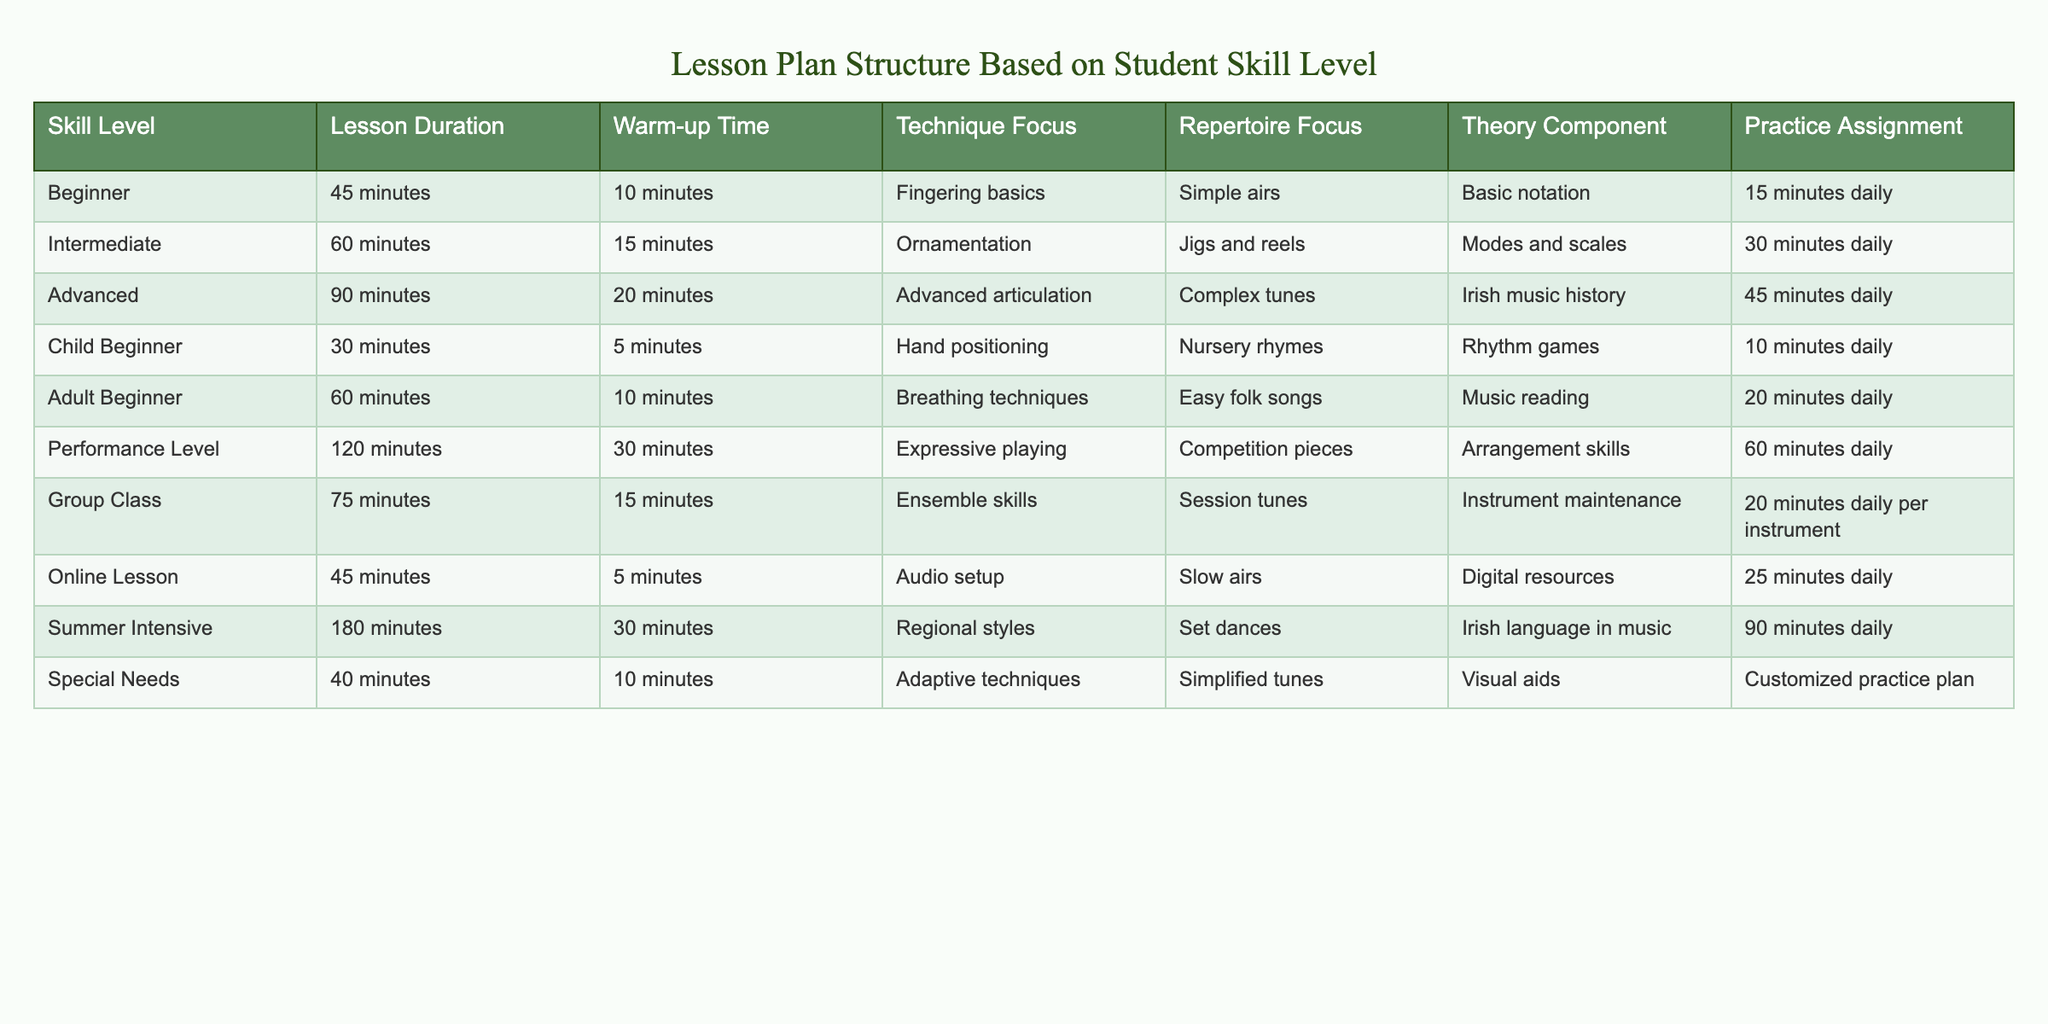What is the lesson duration for a beginner? According to the table, the lesson duration for a beginner is 45 minutes, as stated in the "Lesson Duration" column for the "Beginner" skill level.
Answer: 45 minutes How much warm-up time is allocated for the performance level? The table indicates that the warm-up time for the performance level is 30 minutes, as found in the "Warm-up Time" column for that skill level.
Answer: 30 minutes Which skill level has the longest lesson duration? By examining the “Lesson Duration” column, the performance level has the longest lesson duration of 120 minutes, which is the highest value in that column.
Answer: Performance Level Is the practice assignment for child beginners longer than for adult beginners? The practice assignment for child beginners is 10 minutes daily while for adult beginners it is 20 minutes daily. Therefore, it is not longer for child beginners; it is shorter.
Answer: No What is the combined lesson duration for intermediate and advanced students? The lesson duration for intermediate students is 60 minutes and for advanced students is 90 minutes. Adding these together: 60 + 90 = 150 minutes.
Answer: 150 minutes How many skill levels have a warm-up time of 10 minutes or less? From the table, the skill levels with a warm-up time of 10 minutes or less are beginner (10 minutes), child beginner (5 minutes), adult beginner (10 minutes), and special needs (10 minutes). This totals to four skill levels.
Answer: 4 What is the average practice assignment time across all skill levels? The practice assignment times are 15, 30, 45, 10, 20, 60, 20, 25, 90, and customized practice plan. Ignoring the qualitative last item and summing the rest gives (15 + 30 + 45 + 10 + 20 + 60 + 20 + 25 + 90) = 315 minutes over 9 levels. Therefore, the average is 315 / 9 = 35 minutes.
Answer: 35 minutes Do all skill levels include a theory component in their lesson plans? A review of the table shows that every skill level has a theory component specified, so the answer is yes; all skill levels include a theory component.
Answer: Yes What is the practice assignment time difference between the performance level and child beginner? The performance level's practice assignment is 60 minutes daily, while for child beginners, it is 10 minutes daily. The difference is calculated as 60 - 10 = 50 minutes.
Answer: 50 minutes 